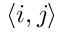Convert formula to latex. <formula><loc_0><loc_0><loc_500><loc_500>\left \langle i , j \right \rangle</formula> 